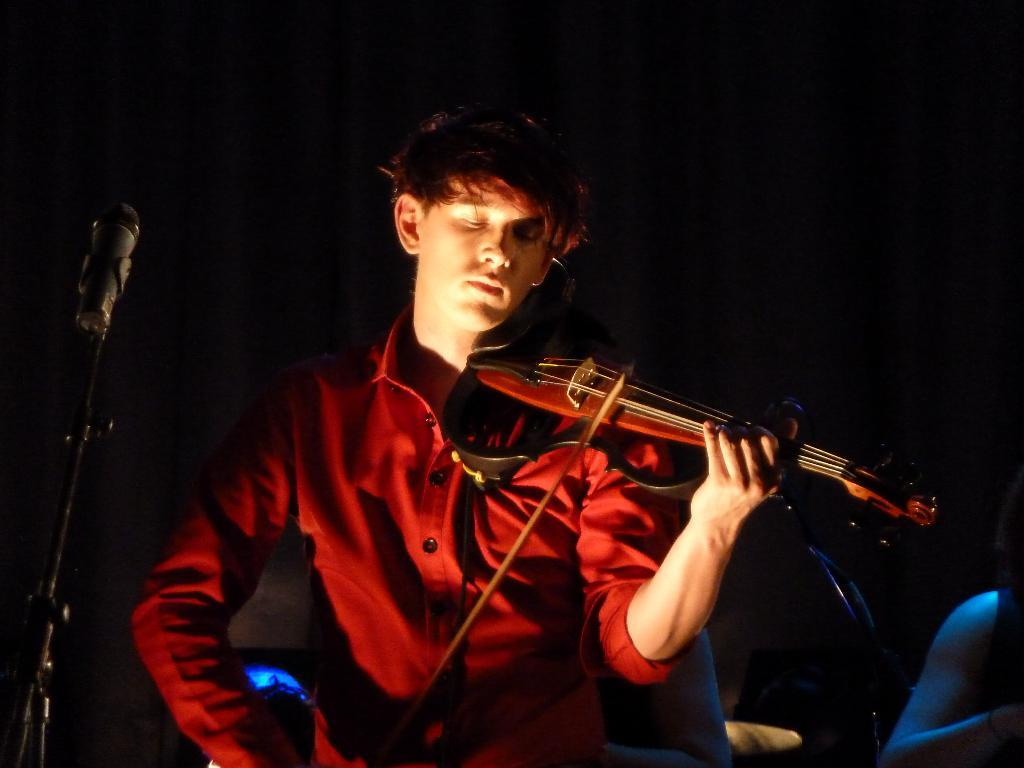What is the man in the image doing? The man is playing a musical instrument in the image. What is present in the image to amplify the man's voice? There is a microphone and stand in the image. What can be seen at the back side of the image? There is a curtain at the back side of the image. What type of list is hanging on the wall in the image? There is no list present in the image; it only features a man playing a musical instrument, a microphone and stand, and a curtain at the back side. 